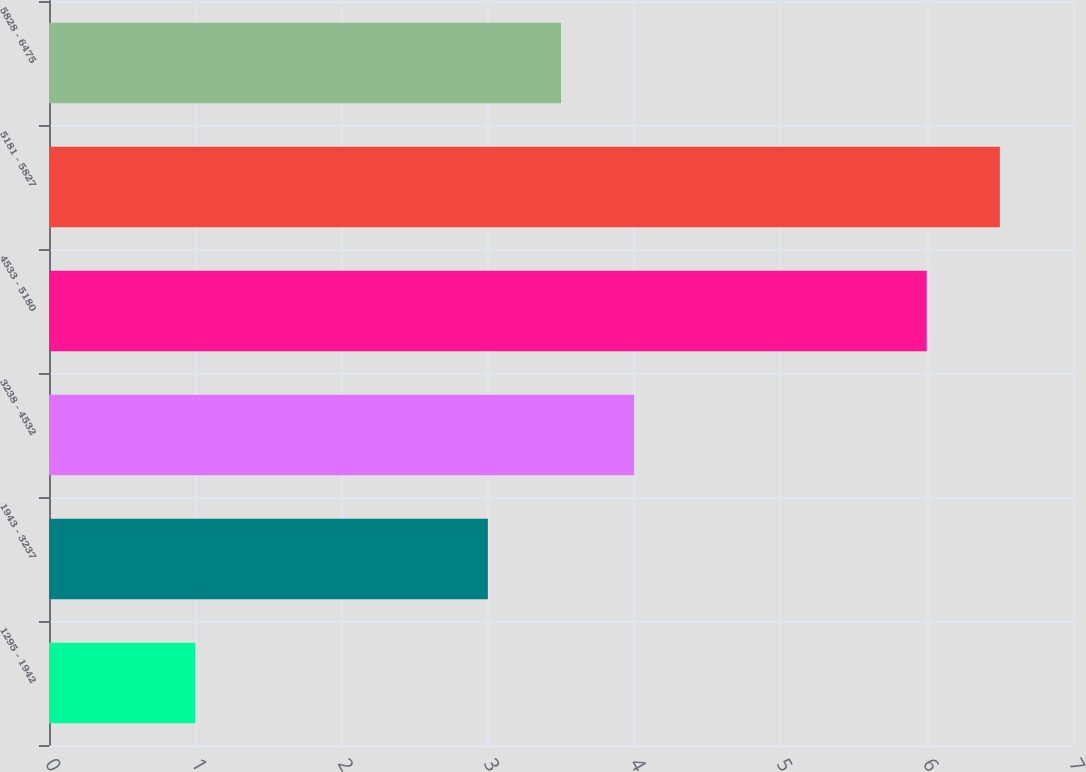Convert chart. <chart><loc_0><loc_0><loc_500><loc_500><bar_chart><fcel>1295 - 1942<fcel>1943 - 3237<fcel>3238 - 4532<fcel>4533 - 5180<fcel>5181 - 5827<fcel>5828 - 6475<nl><fcel>1<fcel>3<fcel>4<fcel>6<fcel>6.5<fcel>3.5<nl></chart> 